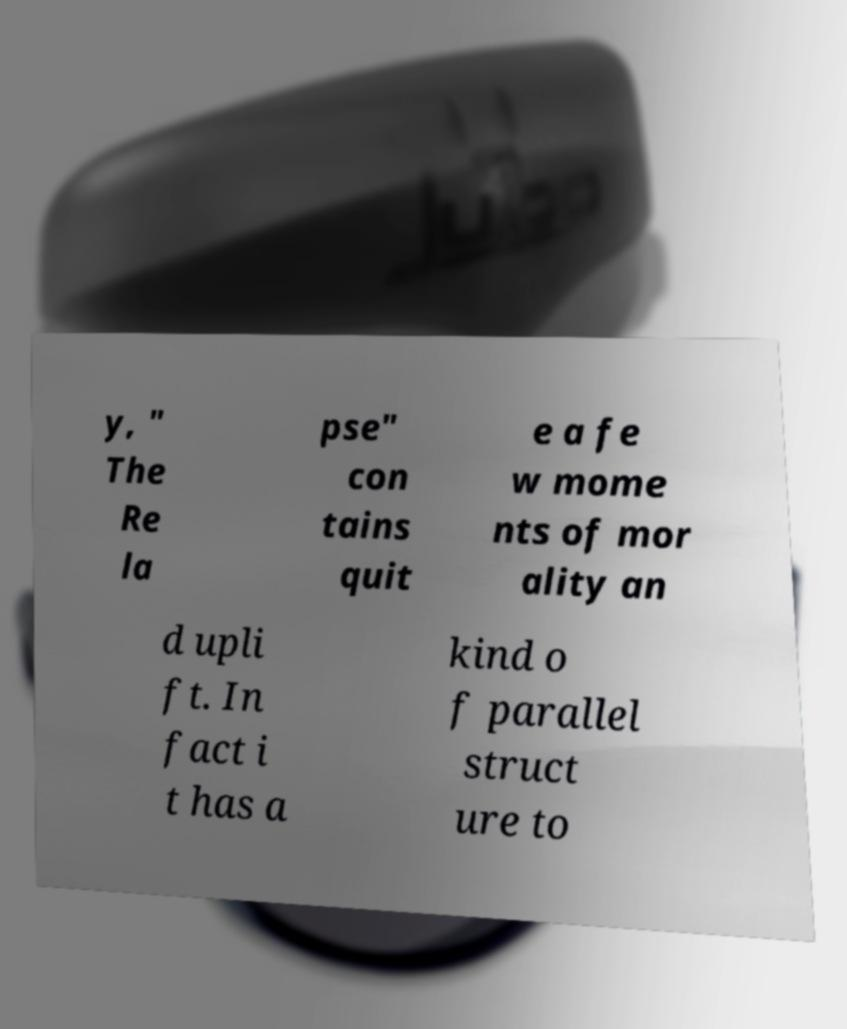Could you assist in decoding the text presented in this image and type it out clearly? y, " The Re la pse" con tains quit e a fe w mome nts of mor ality an d upli ft. In fact i t has a kind o f parallel struct ure to 